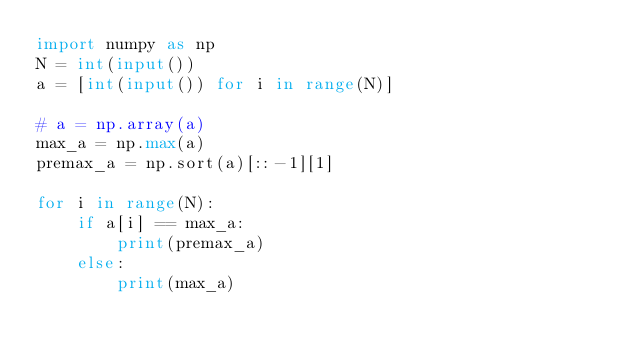Convert code to text. <code><loc_0><loc_0><loc_500><loc_500><_Python_>import numpy as np
N = int(input())
a = [int(input()) for i in range(N)]

# a = np.array(a)
max_a = np.max(a)
premax_a = np.sort(a)[::-1][1]

for i in range(N):
    if a[i] == max_a:
        print(premax_a)
    else:
        print(max_a)</code> 